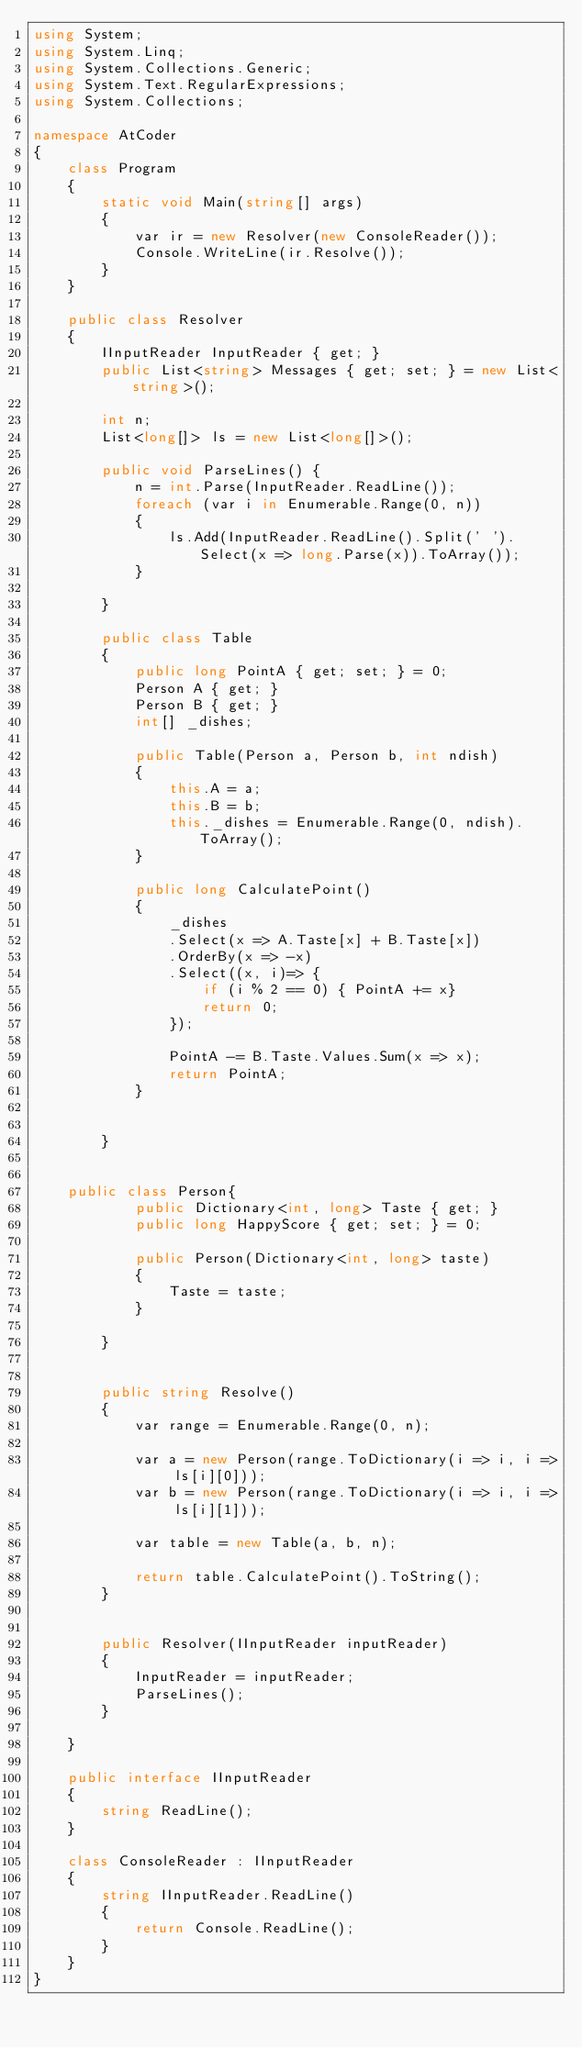Convert code to text. <code><loc_0><loc_0><loc_500><loc_500><_C#_>using System;
using System.Linq;
using System.Collections.Generic;
using System.Text.RegularExpressions;
using System.Collections;

namespace AtCoder
{
    class Program
    {
        static void Main(string[] args)
        {
            var ir = new Resolver(new ConsoleReader());
            Console.WriteLine(ir.Resolve());
        }
    }

    public class Resolver
    {
        IInputReader InputReader { get; }
        public List<string> Messages { get; set; } = new List<string>();

        int n;
        List<long[]> ls = new List<long[]>();

        public void ParseLines() {
            n = int.Parse(InputReader.ReadLine());
            foreach (var i in Enumerable.Range(0, n))
            {
                ls.Add(InputReader.ReadLine().Split(' ').Select(x => long.Parse(x)).ToArray());
            }

        }

        public class Table
        {
            public long PointA { get; set; } = 0;
            Person A { get; }
            Person B { get; }
            int[] _dishes;

            public Table(Person a, Person b, int ndish)
            {
                this.A = a;
                this.B = b;
                this._dishes = Enumerable.Range(0, ndish).ToArray();
            }

            public long CalculatePoint()
            {
                _dishes
                .Select(x => A.Taste[x] + B.Taste[x])
                .OrderBy(x => -x)
                .Select((x, i)=> {
                    if (i % 2 == 0) { PointA += x}
                    return 0;
                });

                PointA -= B.Taste.Values.Sum(x => x);
                return PointA;
            }


        }


    public class Person{
            public Dictionary<int, long> Taste { get; }
            public long HappyScore { get; set; } = 0;

            public Person(Dictionary<int, long> taste)
            {
                Taste = taste;
            }

        }


        public string Resolve()
        {
            var range = Enumerable.Range(0, n);

            var a = new Person(range.ToDictionary(i => i, i => ls[i][0]));
            var b = new Person(range.ToDictionary(i => i, i => ls[i][1]));

            var table = new Table(a, b, n);

            return table.CalculatePoint().ToString();
        }


        public Resolver(IInputReader inputReader)
        {
            InputReader = inputReader;
            ParseLines();
        }

    }

    public interface IInputReader
    {
        string ReadLine();
    }

    class ConsoleReader : IInputReader
    {
        string IInputReader.ReadLine()
        {
            return Console.ReadLine();
        }
    }
}
</code> 